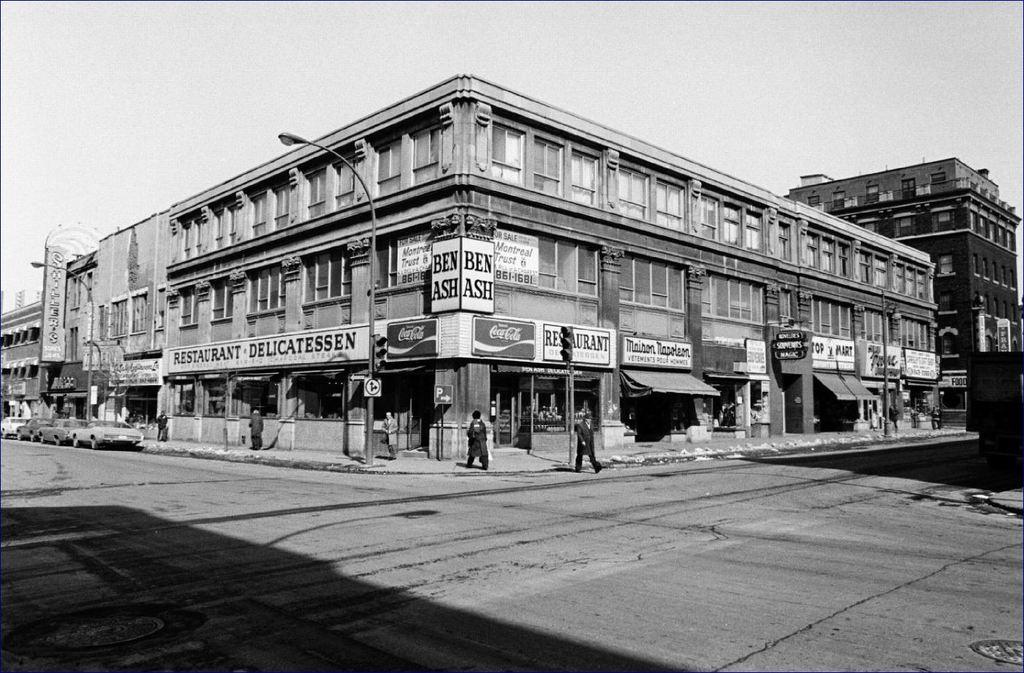What beverage is advertised on the corner of the building?
Offer a terse response. Coca cola. 